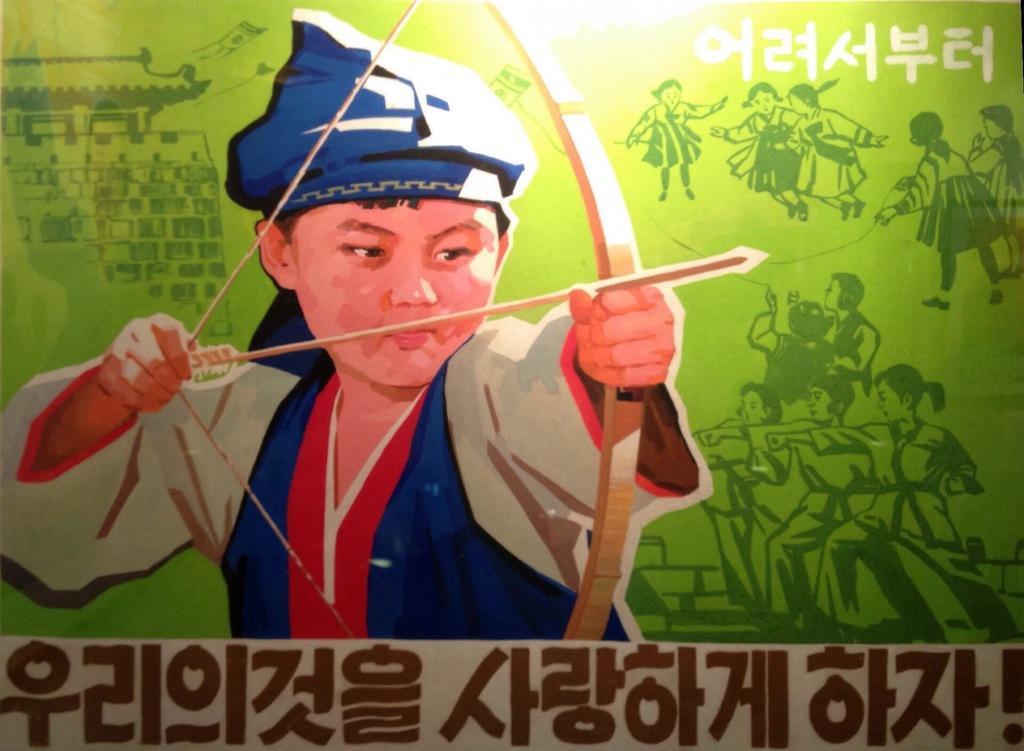Could you give a brief overview of what you see in this image? Here in this picture we can see a banner, on which we can see a child holding a bow and arrow and some other text also painted on it over there. 